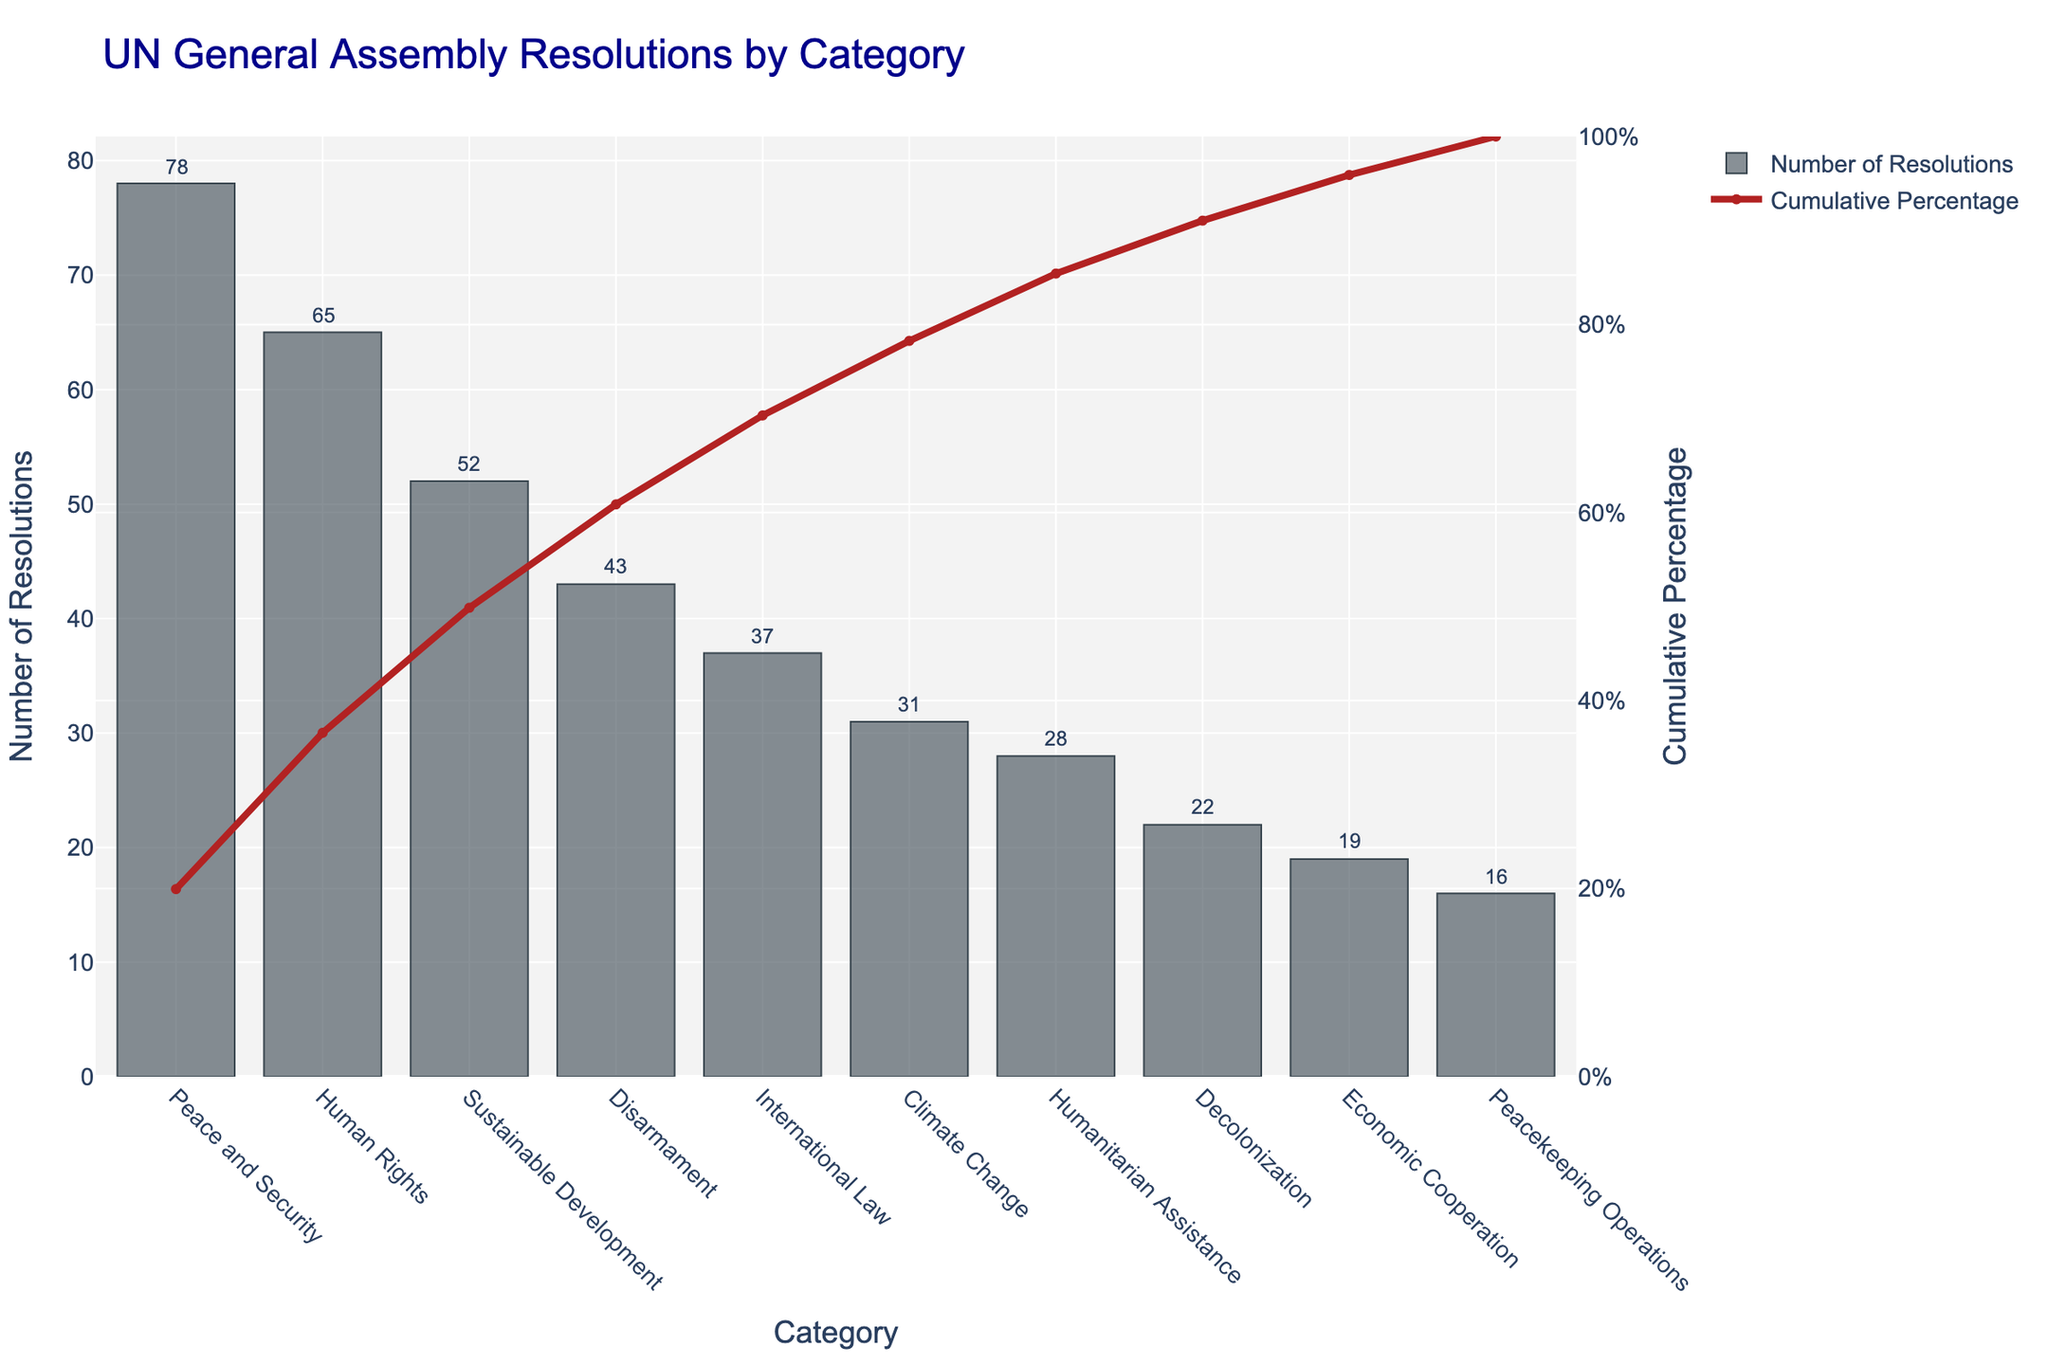What is the most frequent category of UN resolutions? The figure shows the number of resolutions on the y-axis and the categories on the x-axis. The tallest bar represents the most frequent category.
Answer: Peace and Security How many categories have more than 50 resolutions? By inspecting the heights of the bars, only the bars for Peace and Security, and Human Rights have heights above 50.
Answer: 2 What is the percentage contribution of the 'Disarmament' category towards the total number of resolutions? First, identify the number of resolutions in the Disarmament category (43). The total number of resolutions is the sum of all categories: 78 + 65 + 52 + 43 + 37 + 31 + 28 + 22 + 19 + 16 = 391. Hence, the percentage is (43/391) * 100 = 11%.
Answer: 11% What is the sum of resolutions for the 'Humanitarian Assistance' and 'Decolonization' categories? Add the number of resolutions for Humanitarian Assistance (28) and Decolonization (22): 28 + 22 = 50.
Answer: 50 Which category has the smallest number of resolutions? The shortest bar in the chart indicates the category with the smallest number of resolutions.
Answer: Peacekeeping Operations Out of the first three categories, which one contributes the least to the cumulative percentage? The first three categories in order are Peace and Security, Human Rights, and Sustainable Development. The cumulative percentage is the lowest for Sustainable Development.
Answer: Sustainable Development Is there any category that contributes less than 5% to the total number of resolutions? Calculate the percentage for each category from the total. Economic Cooperation has 19 resolutions. (19/391) * 100 ≈ 4.86%, so it is the only one under 5%.
Answer: Yes, Economic Cooperation How much more frequent are resolutions in the 'Peace and Security' category compared to 'Climate Change'? The resolutions for Peace and Security are 78, and for Climate Change are 31. The difference is 78 - 31 = 47.
Answer: 47 What is the cumulative percentage for 'International Law' if sorted in descending order? The cumulative percentage for International Law shown on the secondary y-axis is approximately 72%.
Answer: 72% Which category achieves the 50% cumulative percentage mark? The cumulative percentage line intersects the 50% mark between Human Rights and Sustainable Development. Hence, Sustainable Development brings it above the 50% mark.
Answer: Sustainable Development 